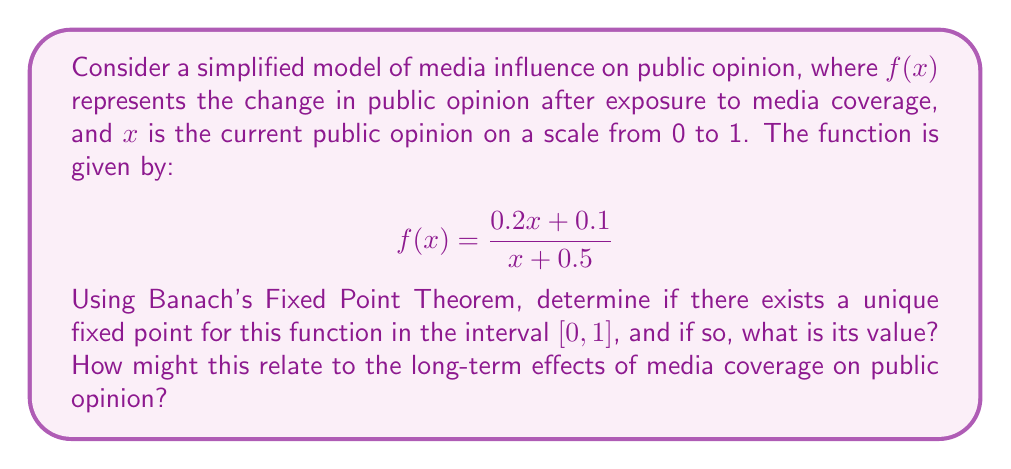Solve this math problem. To apply Banach's Fixed Point Theorem, we need to show that $f$ is a contraction mapping on $[0,1]$.

Step 1: Check if $f$ maps $[0,1]$ to itself.
For $x \in [0,1]$:
$$0 \leq \frac{0.2x + 0.1}{x + 0.5} \leq \frac{0.2 + 0.1}{0.5} = 0.6 < 1$$
So, $f$ maps $[0,1]$ to itself.

Step 2: Show that $f$ is a contraction mapping.
Calculate $f'(x)$:
$$f'(x) = \frac{0.2(x+0.5) - (0.2x+0.1)}{(x+0.5)^2} = \frac{0.1-0.1x}{(x+0.5)^2}$$

For $x \in [0,1]$:
$$|f'(x)| = \left|\frac{0.1-0.1x}{(x+0.5)^2}\right| \leq \frac{0.1}{(0.5)^2} = 0.4 < 1$$

Therefore, $f$ is a contraction mapping on $[0,1]$.

Step 3: Apply Banach's Fixed Point Theorem.
Since $f$ is a contraction mapping on a complete metric space $[0,1]$, there exists a unique fixed point.

Step 4: Find the fixed point.
Solve $x = f(x)$:
$$x = \frac{0.2x + 0.1}{x + 0.5}$$
$$x^2 + 0.5x = 0.2x + 0.1$$
$$x^2 + 0.3x - 0.1 = 0$$

Using the quadratic formula:
$$x = \frac{-0.3 \pm \sqrt{0.3^2 + 4(0.1)}}{2} = \frac{-0.3 \pm \sqrt{0.49}}{2}$$
$$x = \frac{-0.3 + 0.7}{2} = 0.2$$

The negative root is discarded as it's outside $[0,1]$.

Interpretation: The fixed point at 0.2 represents a stable equilibrium in public opinion after repeated exposure to media coverage. This suggests that, in this model, long-term media influence tends to converge public opinion towards a specific point, regardless of the initial opinion.
Answer: 0.2 